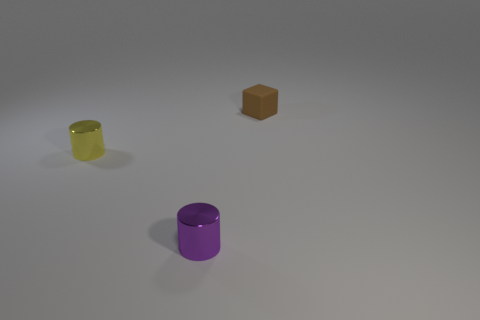Is the number of tiny blocks that are left of the purple metal thing the same as the number of big brown balls?
Keep it short and to the point. Yes. Are there any small yellow things that are left of the thing that is in front of the tiny yellow cylinder?
Make the answer very short. Yes. Is there any other thing that is the same color as the small block?
Keep it short and to the point. No. Does the object on the left side of the small purple metallic cylinder have the same material as the small brown object?
Provide a short and direct response. No. Are there the same number of small yellow shiny cylinders in front of the small yellow shiny cylinder and cylinders behind the matte object?
Provide a succinct answer. Yes. There is a metal cylinder that is in front of the metallic cylinder behind the purple metal thing; what is its size?
Make the answer very short. Small. The object that is in front of the brown cube and behind the tiny purple shiny object is made of what material?
Give a very brief answer. Metal. What number of other objects are there of the same size as the yellow object?
Provide a short and direct response. 2. What color is the rubber thing?
Make the answer very short. Brown. Does the cylinder that is in front of the yellow thing have the same color as the rubber thing on the right side of the yellow metal cylinder?
Your answer should be very brief. No. 